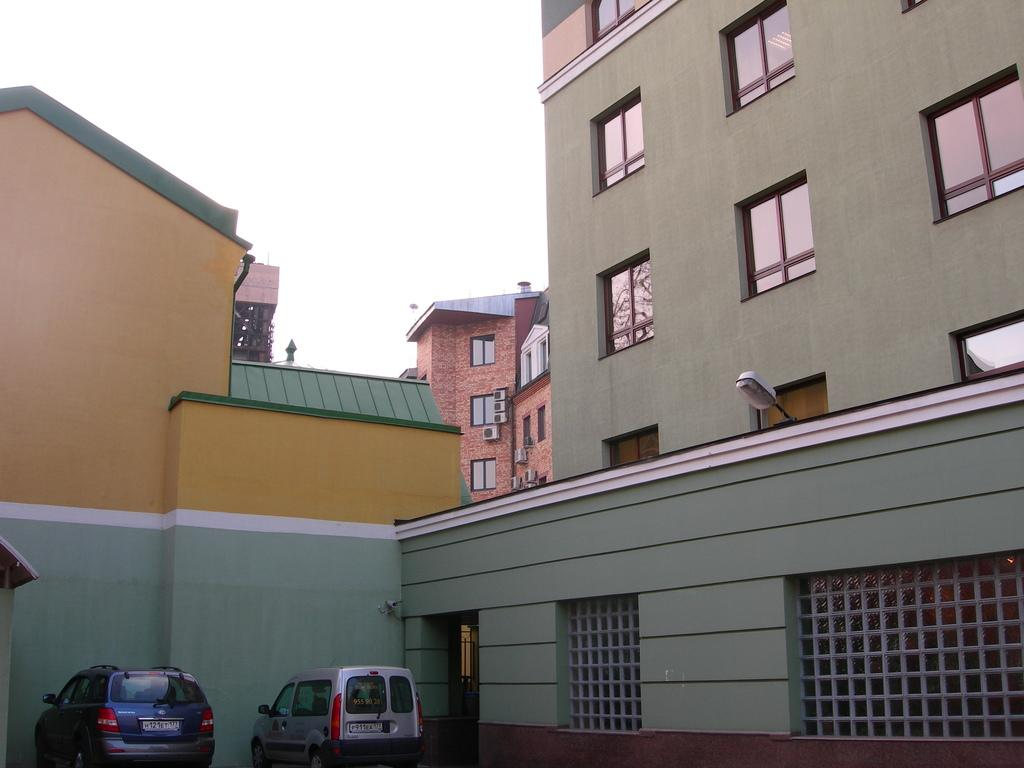What type of structures can be seen in the image? There are buildings in the image. What vehicles are present in the image? There are cars in the image. What part of the natural environment is visible in the image? The sky is visible in the background of the image. What type of shoes can be seen on the buildings in the image? There are no shoes present on the buildings in the image. What subject is being taught in the image? There is no teaching or classroom setting depicted in the image. 